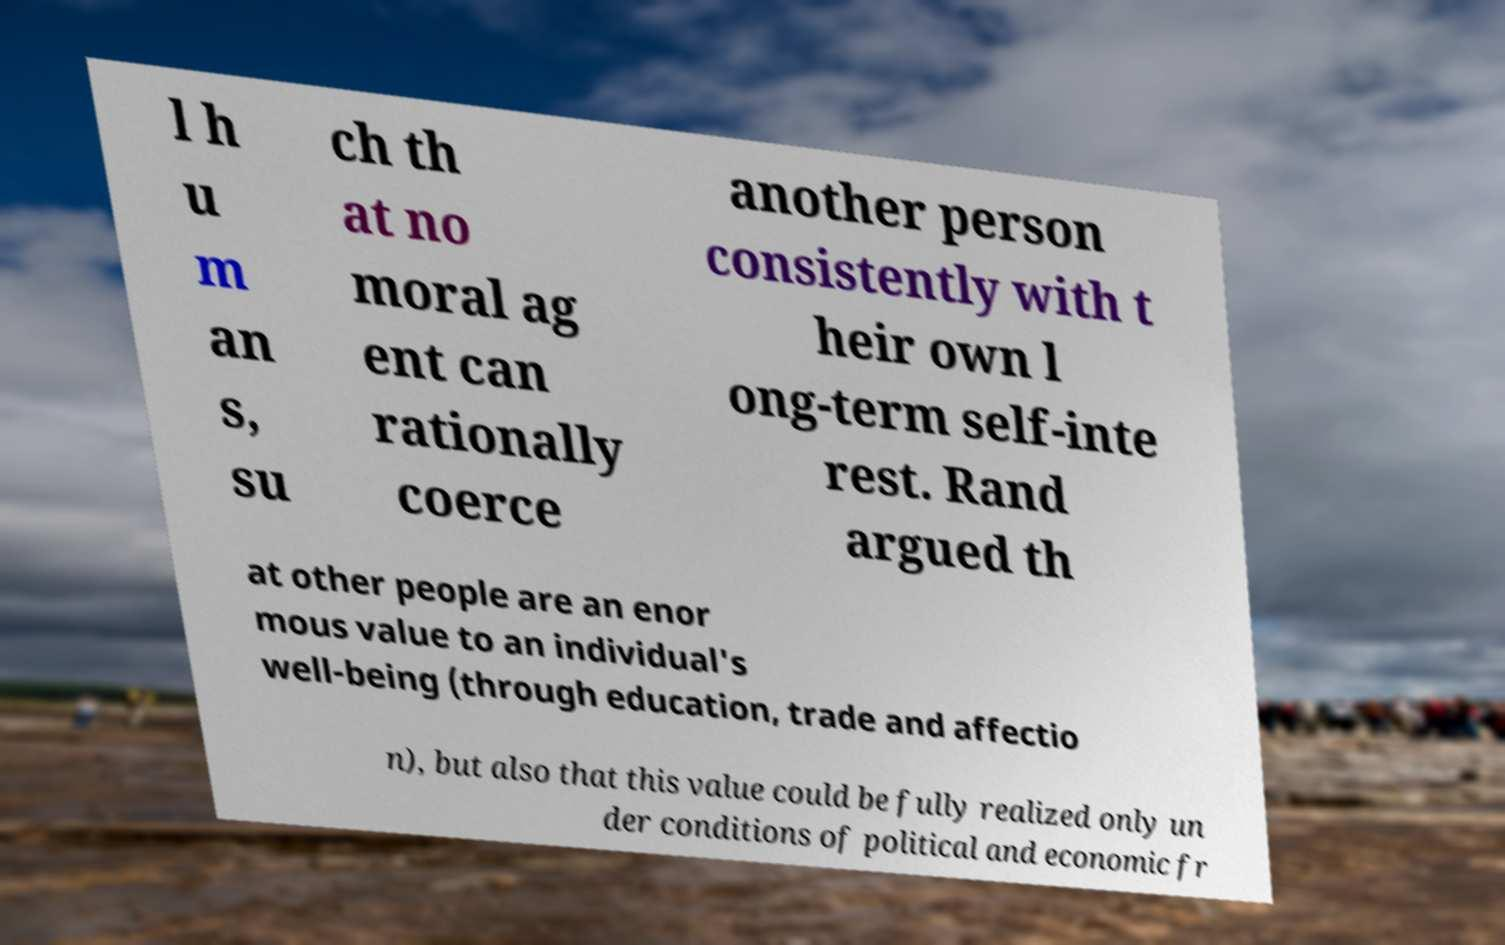I need the written content from this picture converted into text. Can you do that? l h u m an s, su ch th at no moral ag ent can rationally coerce another person consistently with t heir own l ong-term self-inte rest. Rand argued th at other people are an enor mous value to an individual's well-being (through education, trade and affectio n), but also that this value could be fully realized only un der conditions of political and economic fr 